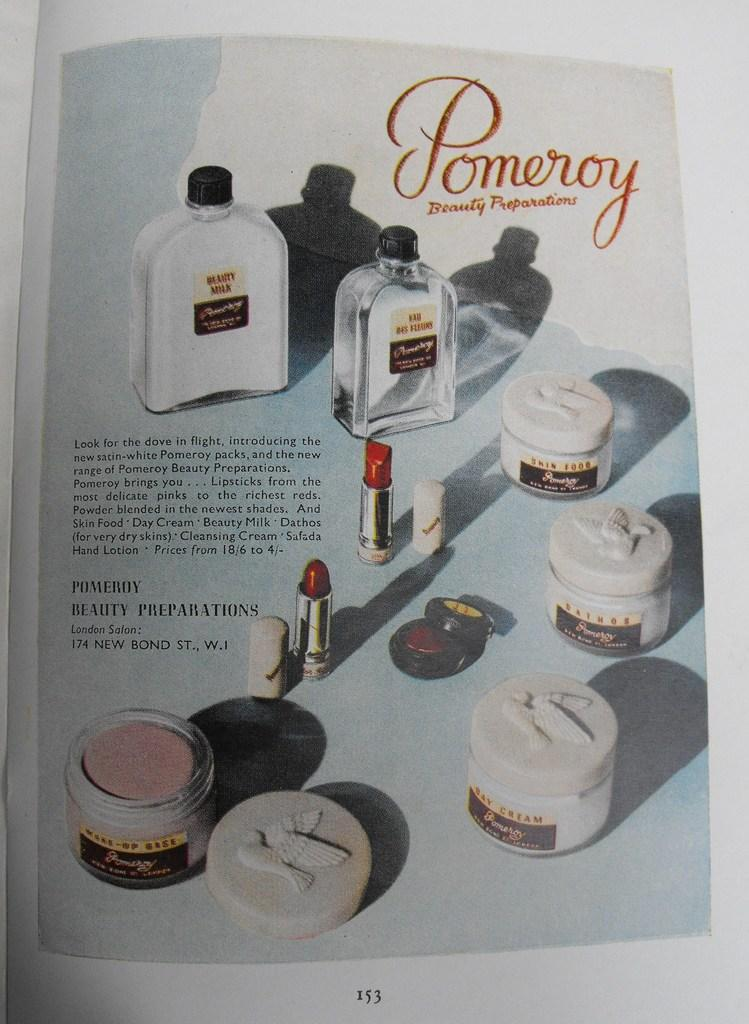Provide a one-sentence caption for the provided image. An advertisement in a magazine for Pomeroy Beauty Preparations.. 